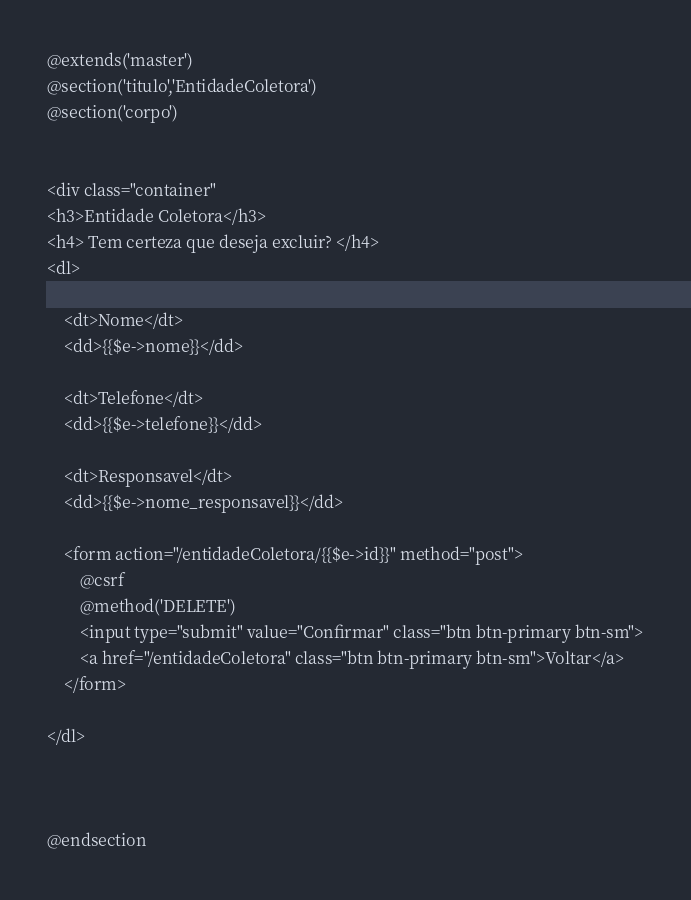Convert code to text. <code><loc_0><loc_0><loc_500><loc_500><_PHP_>@extends('master')
@section('titulo','EntidadeColetora')
@section('corpo')


<div class="container"
<h3>Entidade Coletora</h3>
<h4> Tem certeza que deseja excluir? </h4>
<dl>

	<dt>Nome</dt>
	<dd>{{$e->nome}}</dd>

	<dt>Telefone</dt>
	<dd>{{$e->telefone}}</dd>

	<dt>Responsavel</dt>
	<dd>{{$e->nome_responsavel}}</dd>

	<form action="/entidadeColetora/{{$e->id}}" method="post">
		@csrf
		@method('DELETE')
		<input type="submit" value="Confirmar" class="btn btn-primary btn-sm">
		<a href="/entidadeColetora" class="btn btn-primary btn-sm">Voltar</a>
	</form>
    
</dl>



@endsection</code> 